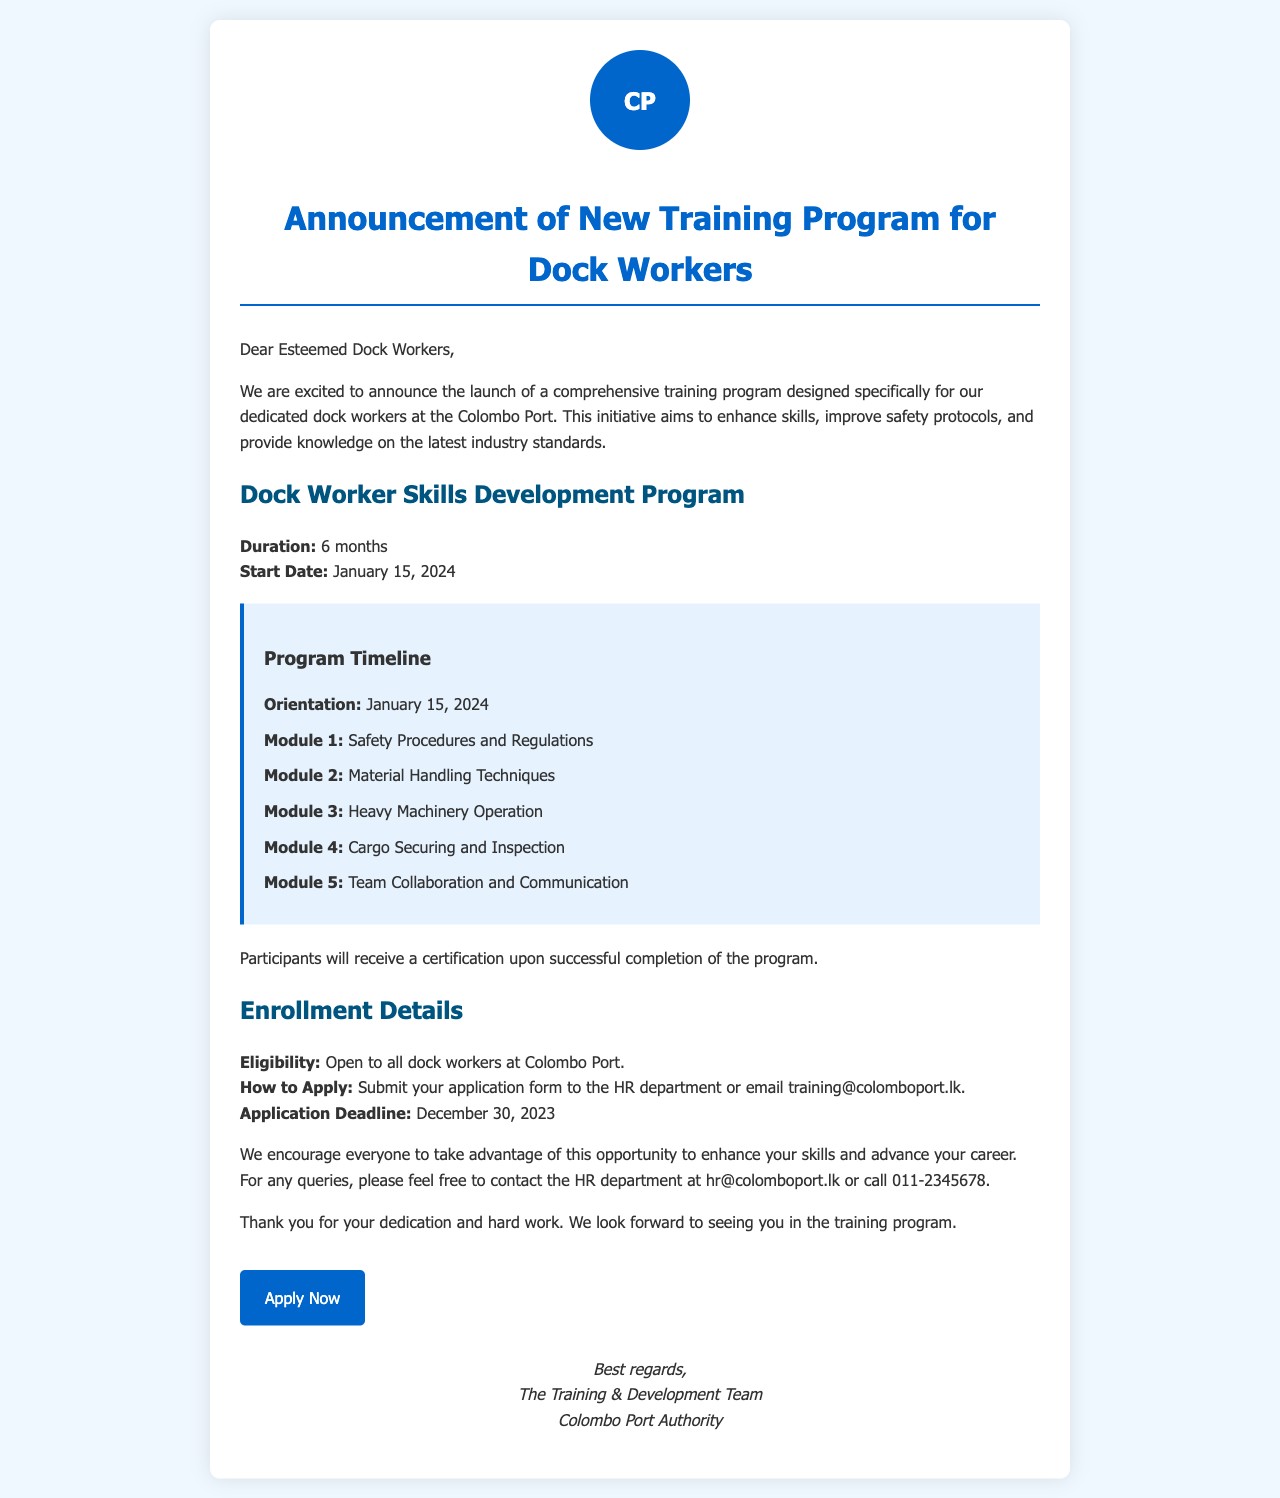What is the duration of the training program? The document states that the training program lasts for 6 months.
Answer: 6 months When does the training program start? The start date of the training program is specified as January 15, 2024.
Answer: January 15, 2024 What is the application deadline? The document indicates that the application deadline is December 30, 2023.
Answer: December 30, 2023 Who can apply for the training program? The program eligibility is open to all dock workers at Colombo Port.
Answer: All dock workers What will participants receive upon completion of the program? The document mentions that participants will receive a certification upon successful completion of the program.
Answer: Certification What module focuses on safety? The first module listed in the timeline is about Safety Procedures and Regulations.
Answer: Safety Procedures and Regulations How can dock workers apply for the program? The document instructs to submit the application form to the HR department or email training@colomboport.lk.
Answer: HR department or email training@colomboport.lk What is the contact number for HR inquiries? The document provides the HR contact number as 011-2345678.
Answer: 011-2345678 Who is the announcement from? The document states that the announcement is from The Training & Development Team, Colombo Port Authority.
Answer: The Training & Development Team, Colombo Port Authority 